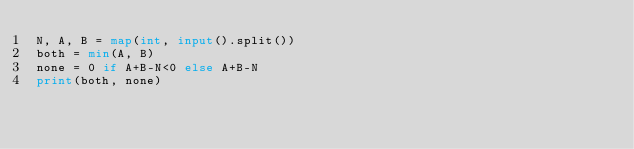<code> <loc_0><loc_0><loc_500><loc_500><_Python_>N, A, B = map(int, input().split())
both = min(A, B)
none = 0 if A+B-N<0 else A+B-N
print(both, none)</code> 